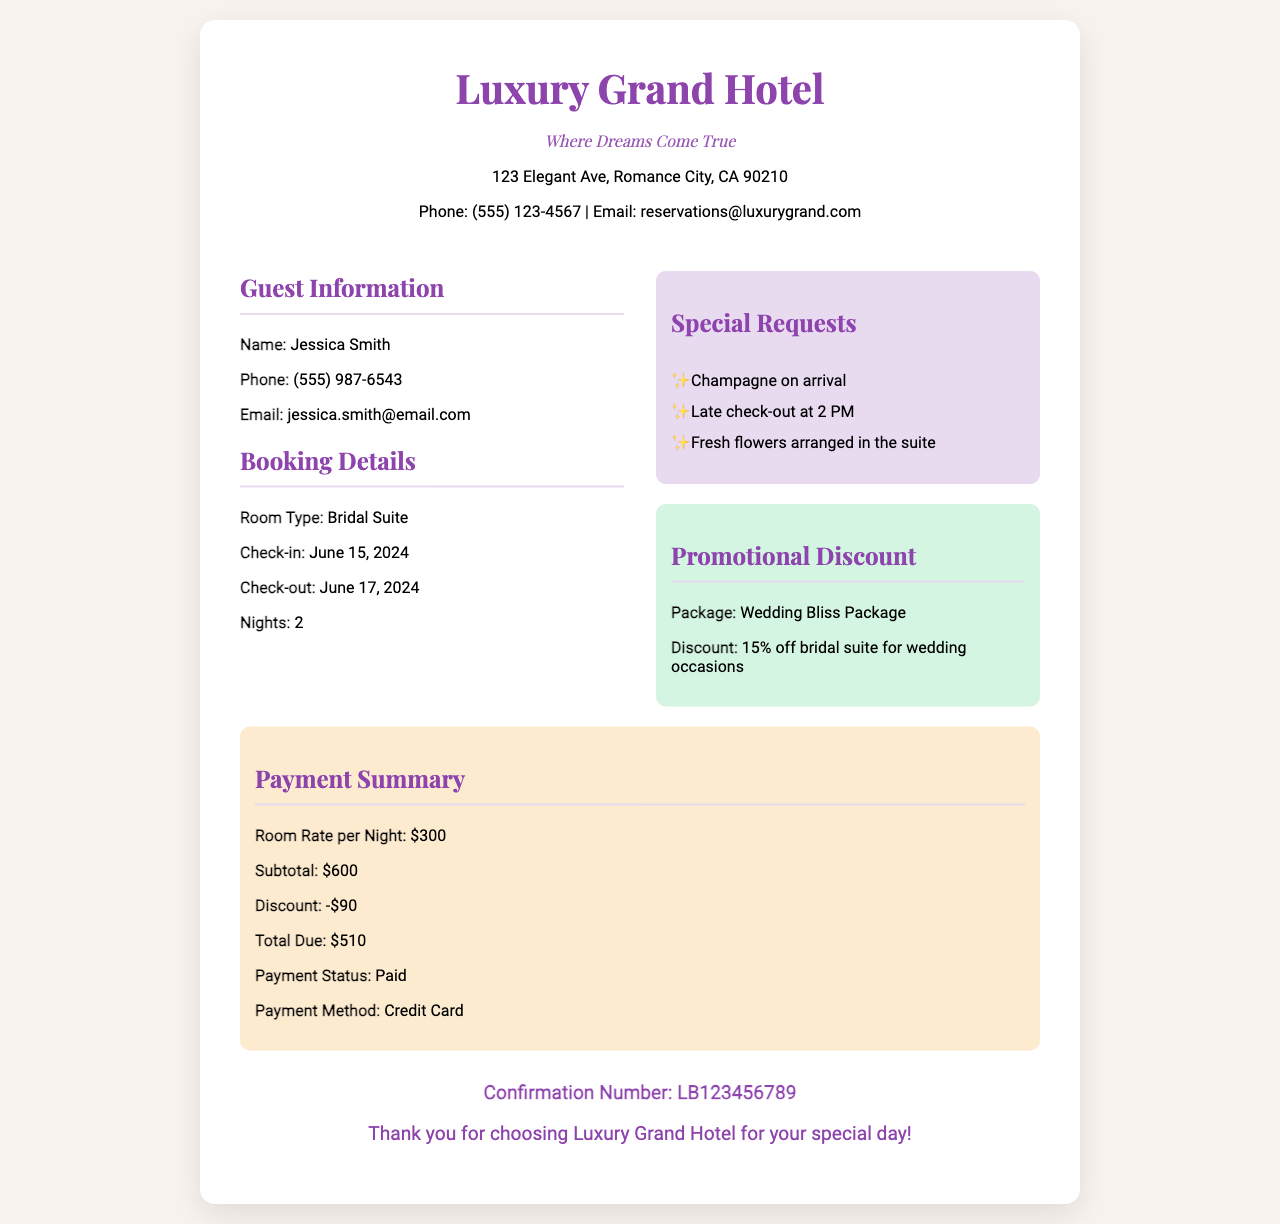What is the name of the guest? The guest's name is listed in the document under Guest Information.
Answer: Jessica Smith What is the total due amount? The total due amount is calculated after applying the discount to the subtotal.
Answer: $510 What are the check-in and check-out dates? The check-in and check-out dates are specified in the Booking Details section of the receipt.
Answer: June 15, 2024 and June 17, 2024 What is the promotional discount percentage? The document specifies the discount percentage associated with the Wedding Bliss Package.
Answer: 15% off How many nights will the guest stay? The number of nights is recorded in the Booking Details section of the receipt.
Answer: 2 What special requests are mentioned? The document outlines specific requests made by the guest in the Special Requests section.
Answer: Champagne on arrival, Late check-out at 2 PM, Fresh flowers arranged in the suite What is the confirmation number? The confirmation number is provided at the bottom of the document.
Answer: LB123456789 What is the payment method used? The payment method is indicated in the Payment Summary section.
Answer: Credit Card What type of room is booked? The type of room booked is mentioned in the Booking Details.
Answer: Bridal Suite 